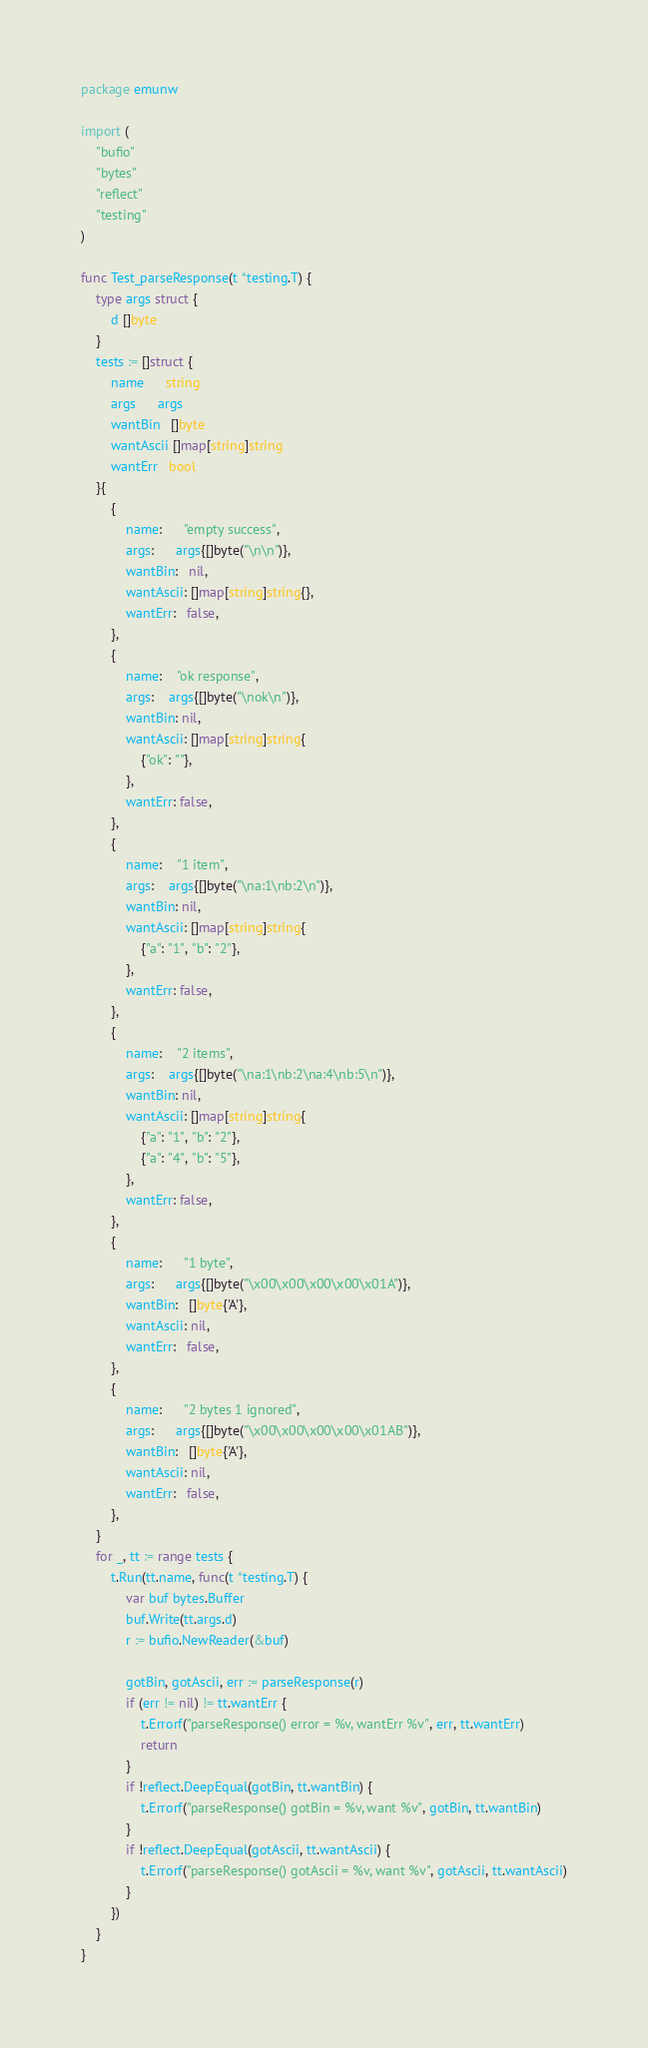Convert code to text. <code><loc_0><loc_0><loc_500><loc_500><_Go_>package emunw

import (
	"bufio"
	"bytes"
	"reflect"
	"testing"
)

func Test_parseResponse(t *testing.T) {
	type args struct {
		d []byte
	}
	tests := []struct {
		name      string
		args      args
		wantBin   []byte
		wantAscii []map[string]string
		wantErr   bool
	}{
		{
			name:      "empty success",
			args:      args{[]byte("\n\n")},
			wantBin:   nil,
			wantAscii: []map[string]string{},
			wantErr:   false,
		},
		{
			name:    "ok response",
			args:    args{[]byte("\nok\n")},
			wantBin: nil,
			wantAscii: []map[string]string{
				{"ok": ""},
			},
			wantErr: false,
		},
		{
			name:    "1 item",
			args:    args{[]byte("\na:1\nb:2\n")},
			wantBin: nil,
			wantAscii: []map[string]string{
				{"a": "1", "b": "2"},
			},
			wantErr: false,
		},
		{
			name:    "2 items",
			args:    args{[]byte("\na:1\nb:2\na:4\nb:5\n")},
			wantBin: nil,
			wantAscii: []map[string]string{
				{"a": "1", "b": "2"},
				{"a": "4", "b": "5"},
			},
			wantErr: false,
		},
		{
			name:      "1 byte",
			args:      args{[]byte("\x00\x00\x00\x00\x01A")},
			wantBin:   []byte{'A'},
			wantAscii: nil,
			wantErr:   false,
		},
		{
			name:      "2 bytes 1 ignored",
			args:      args{[]byte("\x00\x00\x00\x00\x01AB")},
			wantBin:   []byte{'A'},
			wantAscii: nil,
			wantErr:   false,
		},
	}
	for _, tt := range tests {
		t.Run(tt.name, func(t *testing.T) {
			var buf bytes.Buffer
			buf.Write(tt.args.d)
			r := bufio.NewReader(&buf)

			gotBin, gotAscii, err := parseResponse(r)
			if (err != nil) != tt.wantErr {
				t.Errorf("parseResponse() error = %v, wantErr %v", err, tt.wantErr)
				return
			}
			if !reflect.DeepEqual(gotBin, tt.wantBin) {
				t.Errorf("parseResponse() gotBin = %v, want %v", gotBin, tt.wantBin)
			}
			if !reflect.DeepEqual(gotAscii, tt.wantAscii) {
				t.Errorf("parseResponse() gotAscii = %v, want %v", gotAscii, tt.wantAscii)
			}
		})
	}
}
</code> 